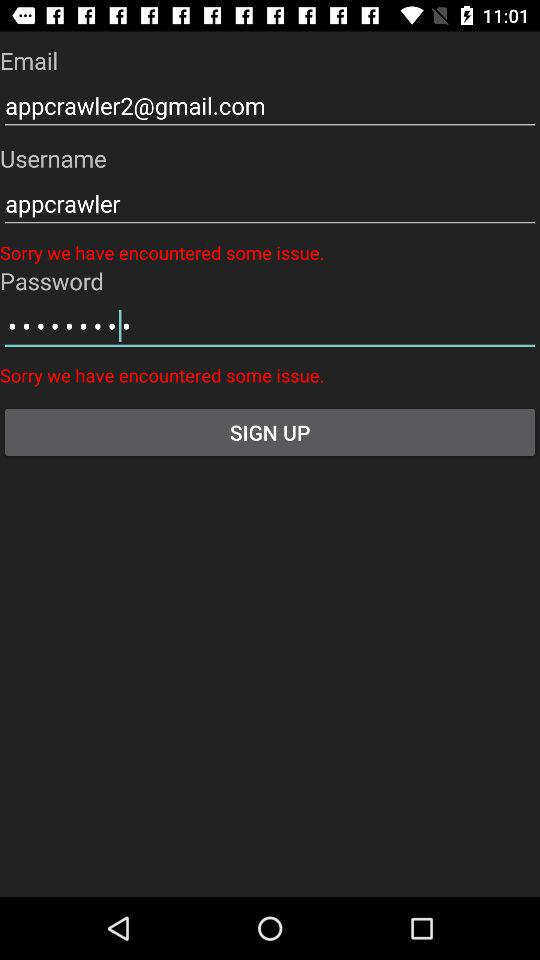How many error messages are displayed on the signup form?
Answer the question using a single word or phrase. 2 